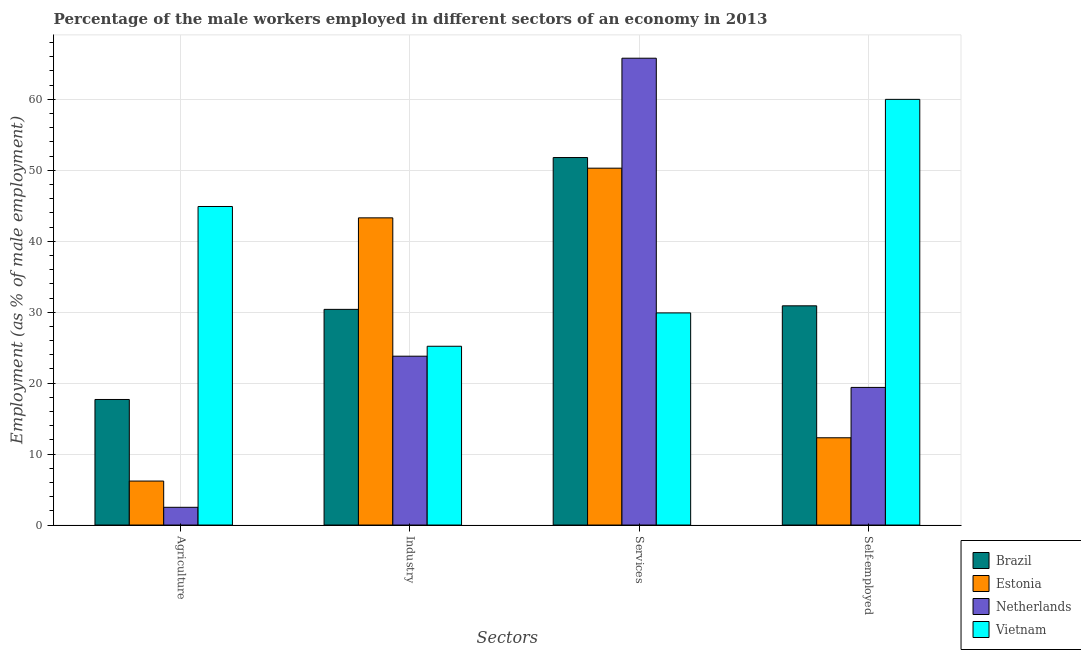How many different coloured bars are there?
Your response must be concise. 4. Are the number of bars per tick equal to the number of legend labels?
Your response must be concise. Yes. How many bars are there on the 2nd tick from the left?
Offer a terse response. 4. What is the label of the 1st group of bars from the left?
Your response must be concise. Agriculture. What is the percentage of male workers in services in Vietnam?
Your answer should be very brief. 29.9. Across all countries, what is the maximum percentage of male workers in services?
Offer a terse response. 65.8. Across all countries, what is the minimum percentage of male workers in services?
Offer a terse response. 29.9. In which country was the percentage of male workers in services maximum?
Offer a terse response. Netherlands. In which country was the percentage of male workers in services minimum?
Ensure brevity in your answer.  Vietnam. What is the total percentage of male workers in services in the graph?
Give a very brief answer. 197.8. What is the difference between the percentage of male workers in industry in Brazil and that in Vietnam?
Your answer should be compact. 5.2. What is the difference between the percentage of male workers in industry in Brazil and the percentage of male workers in services in Vietnam?
Keep it short and to the point. 0.5. What is the average percentage of male workers in agriculture per country?
Offer a very short reply. 17.83. What is the difference between the percentage of male workers in industry and percentage of male workers in agriculture in Netherlands?
Ensure brevity in your answer.  21.3. In how many countries, is the percentage of male workers in agriculture greater than 60 %?
Your answer should be compact. 0. What is the ratio of the percentage of male workers in agriculture in Brazil to that in Estonia?
Keep it short and to the point. 2.85. Is the percentage of male workers in agriculture in Brazil less than that in Vietnam?
Provide a short and direct response. Yes. Is the difference between the percentage of self employed male workers in Brazil and Estonia greater than the difference between the percentage of male workers in industry in Brazil and Estonia?
Your answer should be compact. Yes. What is the difference between the highest and the second highest percentage of male workers in industry?
Give a very brief answer. 12.9. What is the difference between the highest and the lowest percentage of male workers in agriculture?
Your answer should be very brief. 42.4. In how many countries, is the percentage of male workers in agriculture greater than the average percentage of male workers in agriculture taken over all countries?
Offer a very short reply. 1. Is the sum of the percentage of male workers in industry in Brazil and Estonia greater than the maximum percentage of male workers in services across all countries?
Your answer should be compact. Yes. What does the 3rd bar from the left in Industry represents?
Give a very brief answer. Netherlands. What does the 3rd bar from the right in Self-employed represents?
Make the answer very short. Estonia. Is it the case that in every country, the sum of the percentage of male workers in agriculture and percentage of male workers in industry is greater than the percentage of male workers in services?
Make the answer very short. No. How many countries are there in the graph?
Provide a succinct answer. 4. What is the difference between two consecutive major ticks on the Y-axis?
Your answer should be compact. 10. Does the graph contain grids?
Give a very brief answer. Yes. How many legend labels are there?
Give a very brief answer. 4. How are the legend labels stacked?
Ensure brevity in your answer.  Vertical. What is the title of the graph?
Make the answer very short. Percentage of the male workers employed in different sectors of an economy in 2013. Does "Guinea-Bissau" appear as one of the legend labels in the graph?
Give a very brief answer. No. What is the label or title of the X-axis?
Your response must be concise. Sectors. What is the label or title of the Y-axis?
Provide a short and direct response. Employment (as % of male employment). What is the Employment (as % of male employment) of Brazil in Agriculture?
Your answer should be very brief. 17.7. What is the Employment (as % of male employment) in Estonia in Agriculture?
Your response must be concise. 6.2. What is the Employment (as % of male employment) of Netherlands in Agriculture?
Offer a very short reply. 2.5. What is the Employment (as % of male employment) of Vietnam in Agriculture?
Ensure brevity in your answer.  44.9. What is the Employment (as % of male employment) in Brazil in Industry?
Give a very brief answer. 30.4. What is the Employment (as % of male employment) in Estonia in Industry?
Your response must be concise. 43.3. What is the Employment (as % of male employment) in Netherlands in Industry?
Your answer should be very brief. 23.8. What is the Employment (as % of male employment) in Vietnam in Industry?
Give a very brief answer. 25.2. What is the Employment (as % of male employment) in Brazil in Services?
Keep it short and to the point. 51.8. What is the Employment (as % of male employment) of Estonia in Services?
Make the answer very short. 50.3. What is the Employment (as % of male employment) of Netherlands in Services?
Give a very brief answer. 65.8. What is the Employment (as % of male employment) of Vietnam in Services?
Provide a short and direct response. 29.9. What is the Employment (as % of male employment) of Brazil in Self-employed?
Your answer should be very brief. 30.9. What is the Employment (as % of male employment) in Estonia in Self-employed?
Offer a very short reply. 12.3. What is the Employment (as % of male employment) in Netherlands in Self-employed?
Your response must be concise. 19.4. Across all Sectors, what is the maximum Employment (as % of male employment) in Brazil?
Your response must be concise. 51.8. Across all Sectors, what is the maximum Employment (as % of male employment) in Estonia?
Keep it short and to the point. 50.3. Across all Sectors, what is the maximum Employment (as % of male employment) in Netherlands?
Your response must be concise. 65.8. Across all Sectors, what is the maximum Employment (as % of male employment) of Vietnam?
Your answer should be compact. 60. Across all Sectors, what is the minimum Employment (as % of male employment) in Brazil?
Make the answer very short. 17.7. Across all Sectors, what is the minimum Employment (as % of male employment) of Estonia?
Your response must be concise. 6.2. Across all Sectors, what is the minimum Employment (as % of male employment) of Vietnam?
Give a very brief answer. 25.2. What is the total Employment (as % of male employment) in Brazil in the graph?
Provide a succinct answer. 130.8. What is the total Employment (as % of male employment) of Estonia in the graph?
Offer a very short reply. 112.1. What is the total Employment (as % of male employment) of Netherlands in the graph?
Offer a terse response. 111.5. What is the total Employment (as % of male employment) of Vietnam in the graph?
Offer a very short reply. 160. What is the difference between the Employment (as % of male employment) in Brazil in Agriculture and that in Industry?
Offer a very short reply. -12.7. What is the difference between the Employment (as % of male employment) in Estonia in Agriculture and that in Industry?
Ensure brevity in your answer.  -37.1. What is the difference between the Employment (as % of male employment) of Netherlands in Agriculture and that in Industry?
Your answer should be very brief. -21.3. What is the difference between the Employment (as % of male employment) of Vietnam in Agriculture and that in Industry?
Offer a terse response. 19.7. What is the difference between the Employment (as % of male employment) in Brazil in Agriculture and that in Services?
Give a very brief answer. -34.1. What is the difference between the Employment (as % of male employment) of Estonia in Agriculture and that in Services?
Ensure brevity in your answer.  -44.1. What is the difference between the Employment (as % of male employment) in Netherlands in Agriculture and that in Services?
Your answer should be compact. -63.3. What is the difference between the Employment (as % of male employment) in Vietnam in Agriculture and that in Services?
Offer a very short reply. 15. What is the difference between the Employment (as % of male employment) of Brazil in Agriculture and that in Self-employed?
Make the answer very short. -13.2. What is the difference between the Employment (as % of male employment) of Netherlands in Agriculture and that in Self-employed?
Your answer should be very brief. -16.9. What is the difference between the Employment (as % of male employment) of Vietnam in Agriculture and that in Self-employed?
Give a very brief answer. -15.1. What is the difference between the Employment (as % of male employment) in Brazil in Industry and that in Services?
Offer a very short reply. -21.4. What is the difference between the Employment (as % of male employment) in Netherlands in Industry and that in Services?
Offer a very short reply. -42. What is the difference between the Employment (as % of male employment) of Vietnam in Industry and that in Self-employed?
Offer a terse response. -34.8. What is the difference between the Employment (as % of male employment) in Brazil in Services and that in Self-employed?
Offer a very short reply. 20.9. What is the difference between the Employment (as % of male employment) in Estonia in Services and that in Self-employed?
Give a very brief answer. 38. What is the difference between the Employment (as % of male employment) in Netherlands in Services and that in Self-employed?
Your answer should be very brief. 46.4. What is the difference between the Employment (as % of male employment) of Vietnam in Services and that in Self-employed?
Your answer should be very brief. -30.1. What is the difference between the Employment (as % of male employment) of Brazil in Agriculture and the Employment (as % of male employment) of Estonia in Industry?
Ensure brevity in your answer.  -25.6. What is the difference between the Employment (as % of male employment) in Brazil in Agriculture and the Employment (as % of male employment) in Netherlands in Industry?
Provide a succinct answer. -6.1. What is the difference between the Employment (as % of male employment) of Brazil in Agriculture and the Employment (as % of male employment) of Vietnam in Industry?
Your answer should be compact. -7.5. What is the difference between the Employment (as % of male employment) of Estonia in Agriculture and the Employment (as % of male employment) of Netherlands in Industry?
Ensure brevity in your answer.  -17.6. What is the difference between the Employment (as % of male employment) in Netherlands in Agriculture and the Employment (as % of male employment) in Vietnam in Industry?
Your answer should be compact. -22.7. What is the difference between the Employment (as % of male employment) of Brazil in Agriculture and the Employment (as % of male employment) of Estonia in Services?
Ensure brevity in your answer.  -32.6. What is the difference between the Employment (as % of male employment) of Brazil in Agriculture and the Employment (as % of male employment) of Netherlands in Services?
Your answer should be compact. -48.1. What is the difference between the Employment (as % of male employment) in Estonia in Agriculture and the Employment (as % of male employment) in Netherlands in Services?
Offer a terse response. -59.6. What is the difference between the Employment (as % of male employment) of Estonia in Agriculture and the Employment (as % of male employment) of Vietnam in Services?
Provide a short and direct response. -23.7. What is the difference between the Employment (as % of male employment) in Netherlands in Agriculture and the Employment (as % of male employment) in Vietnam in Services?
Your answer should be very brief. -27.4. What is the difference between the Employment (as % of male employment) of Brazil in Agriculture and the Employment (as % of male employment) of Estonia in Self-employed?
Your response must be concise. 5.4. What is the difference between the Employment (as % of male employment) in Brazil in Agriculture and the Employment (as % of male employment) in Netherlands in Self-employed?
Provide a short and direct response. -1.7. What is the difference between the Employment (as % of male employment) of Brazil in Agriculture and the Employment (as % of male employment) of Vietnam in Self-employed?
Make the answer very short. -42.3. What is the difference between the Employment (as % of male employment) in Estonia in Agriculture and the Employment (as % of male employment) in Vietnam in Self-employed?
Your answer should be compact. -53.8. What is the difference between the Employment (as % of male employment) of Netherlands in Agriculture and the Employment (as % of male employment) of Vietnam in Self-employed?
Your response must be concise. -57.5. What is the difference between the Employment (as % of male employment) of Brazil in Industry and the Employment (as % of male employment) of Estonia in Services?
Make the answer very short. -19.9. What is the difference between the Employment (as % of male employment) of Brazil in Industry and the Employment (as % of male employment) of Netherlands in Services?
Your answer should be compact. -35.4. What is the difference between the Employment (as % of male employment) in Brazil in Industry and the Employment (as % of male employment) in Vietnam in Services?
Offer a very short reply. 0.5. What is the difference between the Employment (as % of male employment) of Estonia in Industry and the Employment (as % of male employment) of Netherlands in Services?
Ensure brevity in your answer.  -22.5. What is the difference between the Employment (as % of male employment) of Brazil in Industry and the Employment (as % of male employment) of Vietnam in Self-employed?
Your answer should be very brief. -29.6. What is the difference between the Employment (as % of male employment) of Estonia in Industry and the Employment (as % of male employment) of Netherlands in Self-employed?
Offer a very short reply. 23.9. What is the difference between the Employment (as % of male employment) in Estonia in Industry and the Employment (as % of male employment) in Vietnam in Self-employed?
Your response must be concise. -16.7. What is the difference between the Employment (as % of male employment) of Netherlands in Industry and the Employment (as % of male employment) of Vietnam in Self-employed?
Offer a very short reply. -36.2. What is the difference between the Employment (as % of male employment) in Brazil in Services and the Employment (as % of male employment) in Estonia in Self-employed?
Ensure brevity in your answer.  39.5. What is the difference between the Employment (as % of male employment) of Brazil in Services and the Employment (as % of male employment) of Netherlands in Self-employed?
Offer a terse response. 32.4. What is the difference between the Employment (as % of male employment) in Estonia in Services and the Employment (as % of male employment) in Netherlands in Self-employed?
Your answer should be very brief. 30.9. What is the average Employment (as % of male employment) of Brazil per Sectors?
Provide a short and direct response. 32.7. What is the average Employment (as % of male employment) of Estonia per Sectors?
Provide a short and direct response. 28.02. What is the average Employment (as % of male employment) of Netherlands per Sectors?
Provide a short and direct response. 27.88. What is the average Employment (as % of male employment) in Vietnam per Sectors?
Provide a succinct answer. 40. What is the difference between the Employment (as % of male employment) of Brazil and Employment (as % of male employment) of Vietnam in Agriculture?
Your answer should be compact. -27.2. What is the difference between the Employment (as % of male employment) in Estonia and Employment (as % of male employment) in Vietnam in Agriculture?
Make the answer very short. -38.7. What is the difference between the Employment (as % of male employment) of Netherlands and Employment (as % of male employment) of Vietnam in Agriculture?
Your answer should be very brief. -42.4. What is the difference between the Employment (as % of male employment) of Brazil and Employment (as % of male employment) of Estonia in Industry?
Provide a short and direct response. -12.9. What is the difference between the Employment (as % of male employment) in Estonia and Employment (as % of male employment) in Vietnam in Industry?
Your response must be concise. 18.1. What is the difference between the Employment (as % of male employment) in Netherlands and Employment (as % of male employment) in Vietnam in Industry?
Provide a short and direct response. -1.4. What is the difference between the Employment (as % of male employment) in Brazil and Employment (as % of male employment) in Vietnam in Services?
Provide a succinct answer. 21.9. What is the difference between the Employment (as % of male employment) in Estonia and Employment (as % of male employment) in Netherlands in Services?
Ensure brevity in your answer.  -15.5. What is the difference between the Employment (as % of male employment) of Estonia and Employment (as % of male employment) of Vietnam in Services?
Ensure brevity in your answer.  20.4. What is the difference between the Employment (as % of male employment) in Netherlands and Employment (as % of male employment) in Vietnam in Services?
Provide a short and direct response. 35.9. What is the difference between the Employment (as % of male employment) in Brazil and Employment (as % of male employment) in Vietnam in Self-employed?
Make the answer very short. -29.1. What is the difference between the Employment (as % of male employment) in Estonia and Employment (as % of male employment) in Netherlands in Self-employed?
Make the answer very short. -7.1. What is the difference between the Employment (as % of male employment) in Estonia and Employment (as % of male employment) in Vietnam in Self-employed?
Ensure brevity in your answer.  -47.7. What is the difference between the Employment (as % of male employment) of Netherlands and Employment (as % of male employment) of Vietnam in Self-employed?
Make the answer very short. -40.6. What is the ratio of the Employment (as % of male employment) in Brazil in Agriculture to that in Industry?
Offer a very short reply. 0.58. What is the ratio of the Employment (as % of male employment) in Estonia in Agriculture to that in Industry?
Offer a terse response. 0.14. What is the ratio of the Employment (as % of male employment) of Netherlands in Agriculture to that in Industry?
Your response must be concise. 0.1. What is the ratio of the Employment (as % of male employment) in Vietnam in Agriculture to that in Industry?
Your answer should be very brief. 1.78. What is the ratio of the Employment (as % of male employment) in Brazil in Agriculture to that in Services?
Offer a very short reply. 0.34. What is the ratio of the Employment (as % of male employment) of Estonia in Agriculture to that in Services?
Offer a terse response. 0.12. What is the ratio of the Employment (as % of male employment) in Netherlands in Agriculture to that in Services?
Your response must be concise. 0.04. What is the ratio of the Employment (as % of male employment) in Vietnam in Agriculture to that in Services?
Your answer should be compact. 1.5. What is the ratio of the Employment (as % of male employment) of Brazil in Agriculture to that in Self-employed?
Make the answer very short. 0.57. What is the ratio of the Employment (as % of male employment) of Estonia in Agriculture to that in Self-employed?
Keep it short and to the point. 0.5. What is the ratio of the Employment (as % of male employment) of Netherlands in Agriculture to that in Self-employed?
Offer a terse response. 0.13. What is the ratio of the Employment (as % of male employment) in Vietnam in Agriculture to that in Self-employed?
Provide a succinct answer. 0.75. What is the ratio of the Employment (as % of male employment) in Brazil in Industry to that in Services?
Your answer should be very brief. 0.59. What is the ratio of the Employment (as % of male employment) of Estonia in Industry to that in Services?
Give a very brief answer. 0.86. What is the ratio of the Employment (as % of male employment) in Netherlands in Industry to that in Services?
Make the answer very short. 0.36. What is the ratio of the Employment (as % of male employment) in Vietnam in Industry to that in Services?
Give a very brief answer. 0.84. What is the ratio of the Employment (as % of male employment) in Brazil in Industry to that in Self-employed?
Your response must be concise. 0.98. What is the ratio of the Employment (as % of male employment) in Estonia in Industry to that in Self-employed?
Provide a short and direct response. 3.52. What is the ratio of the Employment (as % of male employment) in Netherlands in Industry to that in Self-employed?
Give a very brief answer. 1.23. What is the ratio of the Employment (as % of male employment) of Vietnam in Industry to that in Self-employed?
Your response must be concise. 0.42. What is the ratio of the Employment (as % of male employment) in Brazil in Services to that in Self-employed?
Your answer should be very brief. 1.68. What is the ratio of the Employment (as % of male employment) in Estonia in Services to that in Self-employed?
Give a very brief answer. 4.09. What is the ratio of the Employment (as % of male employment) in Netherlands in Services to that in Self-employed?
Offer a terse response. 3.39. What is the ratio of the Employment (as % of male employment) in Vietnam in Services to that in Self-employed?
Ensure brevity in your answer.  0.5. What is the difference between the highest and the second highest Employment (as % of male employment) of Brazil?
Give a very brief answer. 20.9. What is the difference between the highest and the lowest Employment (as % of male employment) in Brazil?
Your answer should be compact. 34.1. What is the difference between the highest and the lowest Employment (as % of male employment) of Estonia?
Your answer should be very brief. 44.1. What is the difference between the highest and the lowest Employment (as % of male employment) of Netherlands?
Your answer should be compact. 63.3. What is the difference between the highest and the lowest Employment (as % of male employment) in Vietnam?
Offer a very short reply. 34.8. 